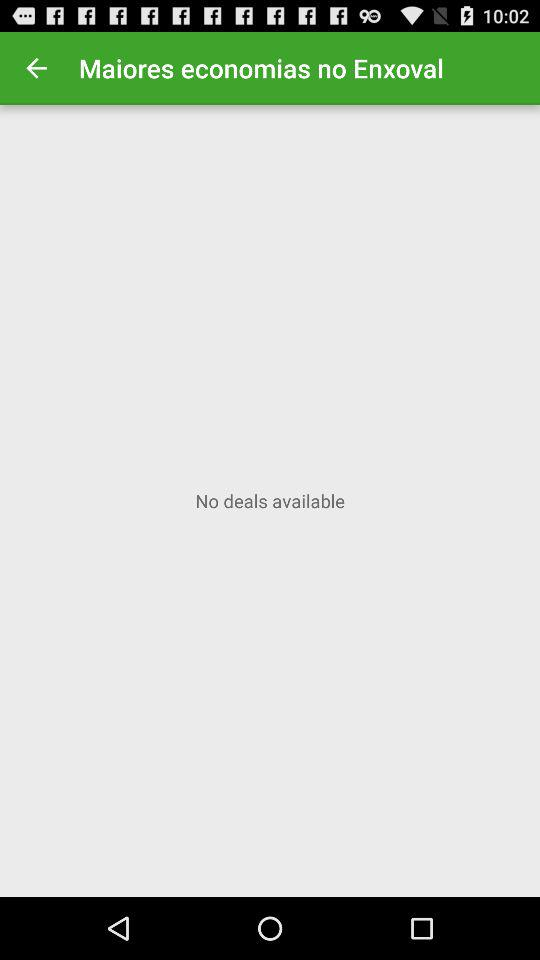Are there any deals available? There are no deals available. 